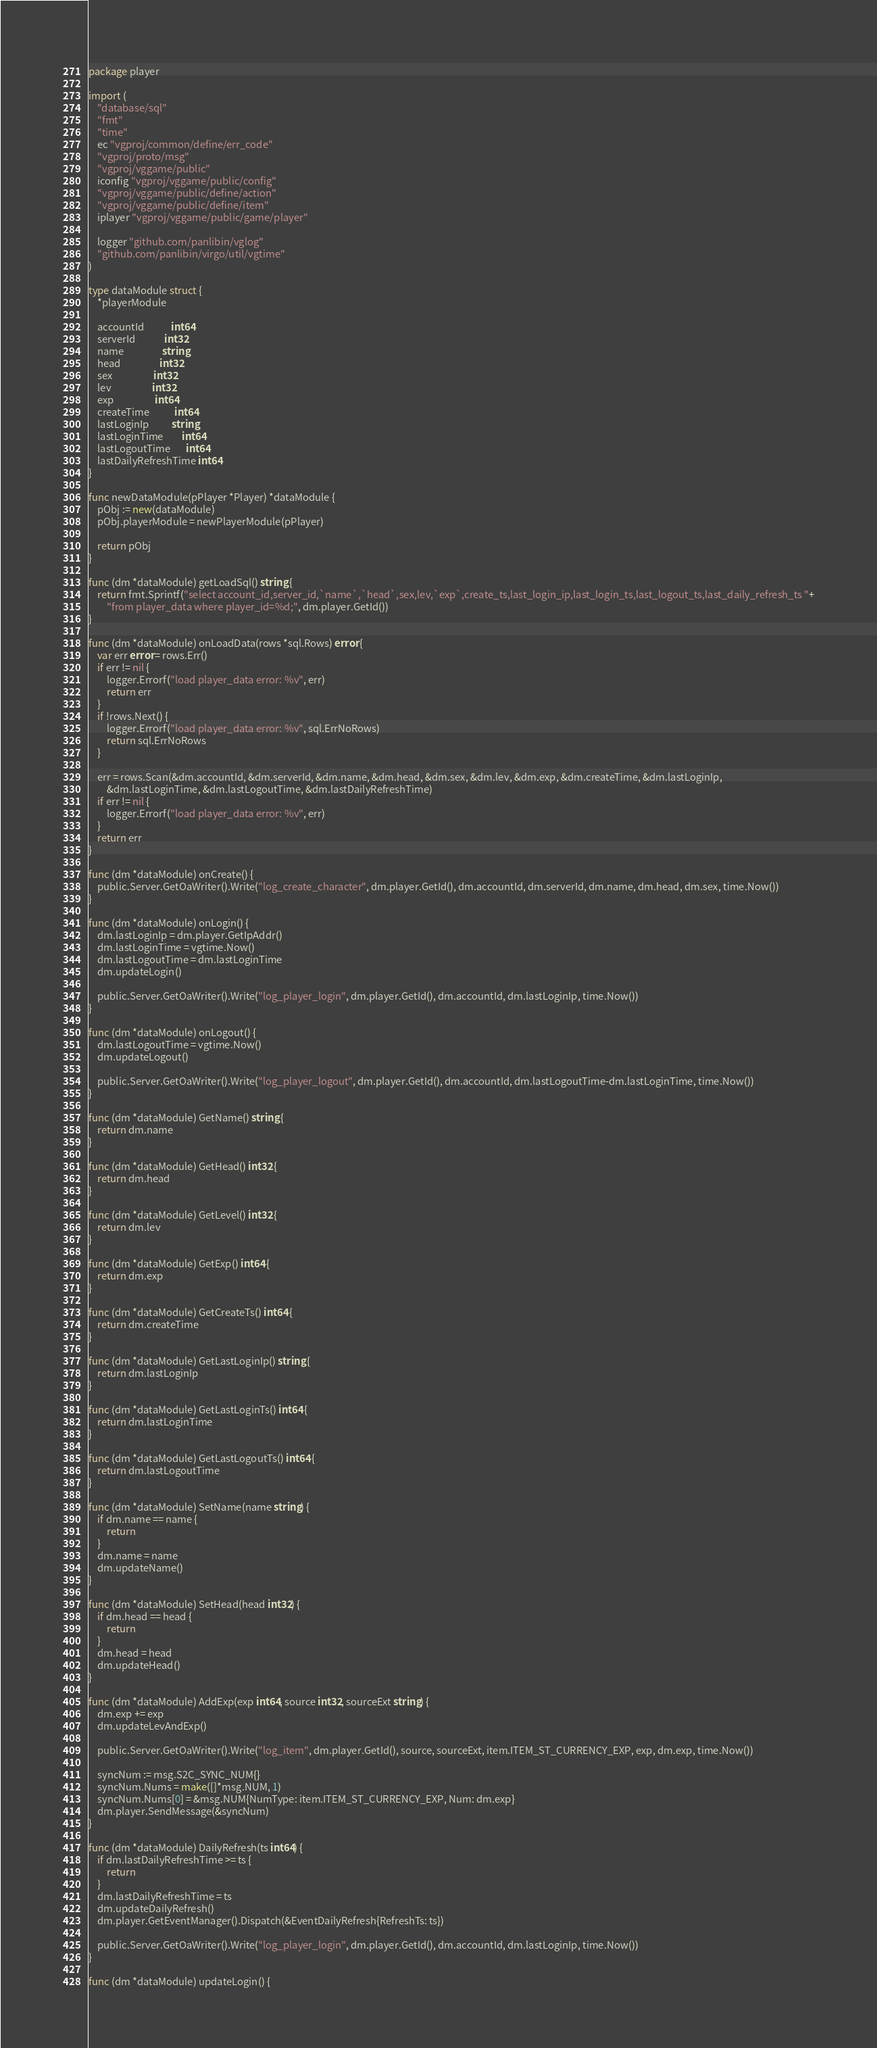<code> <loc_0><loc_0><loc_500><loc_500><_Go_>package player

import (
	"database/sql"
	"fmt"
	"time"
	ec "vgproj/common/define/err_code"
	"vgproj/proto/msg"
	"vgproj/vggame/public"
	iconfig "vgproj/vggame/public/config"
	"vgproj/vggame/public/define/action"
	"vgproj/vggame/public/define/item"
	iplayer "vgproj/vggame/public/game/player"

	logger "github.com/panlibin/vglog"
	"github.com/panlibin/virgo/util/vgtime"
)

type dataModule struct {
	*playerModule

	accountId            int64
	serverId             int32
	name                 string
	head                 int32
	sex                  int32
	lev                  int32
	exp                  int64
	createTime           int64
	lastLoginIp          string
	lastLoginTime        int64
	lastLogoutTime       int64
	lastDailyRefreshTime int64
}

func newDataModule(pPlayer *Player) *dataModule {
	pObj := new(dataModule)
	pObj.playerModule = newPlayerModule(pPlayer)

	return pObj
}

func (dm *dataModule) getLoadSql() string {
	return fmt.Sprintf("select account_id,server_id,`name`,`head`,sex,lev,`exp`,create_ts,last_login_ip,last_login_ts,last_logout_ts,last_daily_refresh_ts "+
		"from player_data where player_id=%d;", dm.player.GetId())
}

func (dm *dataModule) onLoadData(rows *sql.Rows) error {
	var err error = rows.Err()
	if err != nil {
		logger.Errorf("load player_data error: %v", err)
		return err
	}
	if !rows.Next() {
		logger.Errorf("load player_data error: %v", sql.ErrNoRows)
		return sql.ErrNoRows
	}

	err = rows.Scan(&dm.accountId, &dm.serverId, &dm.name, &dm.head, &dm.sex, &dm.lev, &dm.exp, &dm.createTime, &dm.lastLoginIp,
		&dm.lastLoginTime, &dm.lastLogoutTime, &dm.lastDailyRefreshTime)
	if err != nil {
		logger.Errorf("load player_data error: %v", err)
	}
	return err
}

func (dm *dataModule) onCreate() {
	public.Server.GetOaWriter().Write("log_create_character", dm.player.GetId(), dm.accountId, dm.serverId, dm.name, dm.head, dm.sex, time.Now())
}

func (dm *dataModule) onLogin() {
	dm.lastLoginIp = dm.player.GetIpAddr()
	dm.lastLoginTime = vgtime.Now()
	dm.lastLogoutTime = dm.lastLoginTime
	dm.updateLogin()

	public.Server.GetOaWriter().Write("log_player_login", dm.player.GetId(), dm.accountId, dm.lastLoginIp, time.Now())
}

func (dm *dataModule) onLogout() {
	dm.lastLogoutTime = vgtime.Now()
	dm.updateLogout()

	public.Server.GetOaWriter().Write("log_player_logout", dm.player.GetId(), dm.accountId, dm.lastLogoutTime-dm.lastLoginTime, time.Now())
}

func (dm *dataModule) GetName() string {
	return dm.name
}

func (dm *dataModule) GetHead() int32 {
	return dm.head
}

func (dm *dataModule) GetLevel() int32 {
	return dm.lev
}

func (dm *dataModule) GetExp() int64 {
	return dm.exp
}

func (dm *dataModule) GetCreateTs() int64 {
	return dm.createTime
}

func (dm *dataModule) GetLastLoginIp() string {
	return dm.lastLoginIp
}

func (dm *dataModule) GetLastLoginTs() int64 {
	return dm.lastLoginTime
}

func (dm *dataModule) GetLastLogoutTs() int64 {
	return dm.lastLogoutTime
}

func (dm *dataModule) SetName(name string) {
	if dm.name == name {
		return
	}
	dm.name = name
	dm.updateName()
}

func (dm *dataModule) SetHead(head int32) {
	if dm.head == head {
		return
	}
	dm.head = head
	dm.updateHead()
}

func (dm *dataModule) AddExp(exp int64, source int32, sourceExt string) {
	dm.exp += exp
	dm.updateLevAndExp()

	public.Server.GetOaWriter().Write("log_item", dm.player.GetId(), source, sourceExt, item.ITEM_ST_CURRENCY_EXP, exp, dm.exp, time.Now())

	syncNum := msg.S2C_SYNC_NUM{}
	syncNum.Nums = make([]*msg.NUM, 1)
	syncNum.Nums[0] = &msg.NUM{NumType: item.ITEM_ST_CURRENCY_EXP, Num: dm.exp}
	dm.player.SendMessage(&syncNum)
}

func (dm *dataModule) DailyRefresh(ts int64) {
	if dm.lastDailyRefreshTime >= ts {
		return
	}
	dm.lastDailyRefreshTime = ts
	dm.updateDailyRefresh()
	dm.player.GetEventManager().Dispatch(&EventDailyRefresh{RefreshTs: ts})

	public.Server.GetOaWriter().Write("log_player_login", dm.player.GetId(), dm.accountId, dm.lastLoginIp, time.Now())
}

func (dm *dataModule) updateLogin() {</code> 